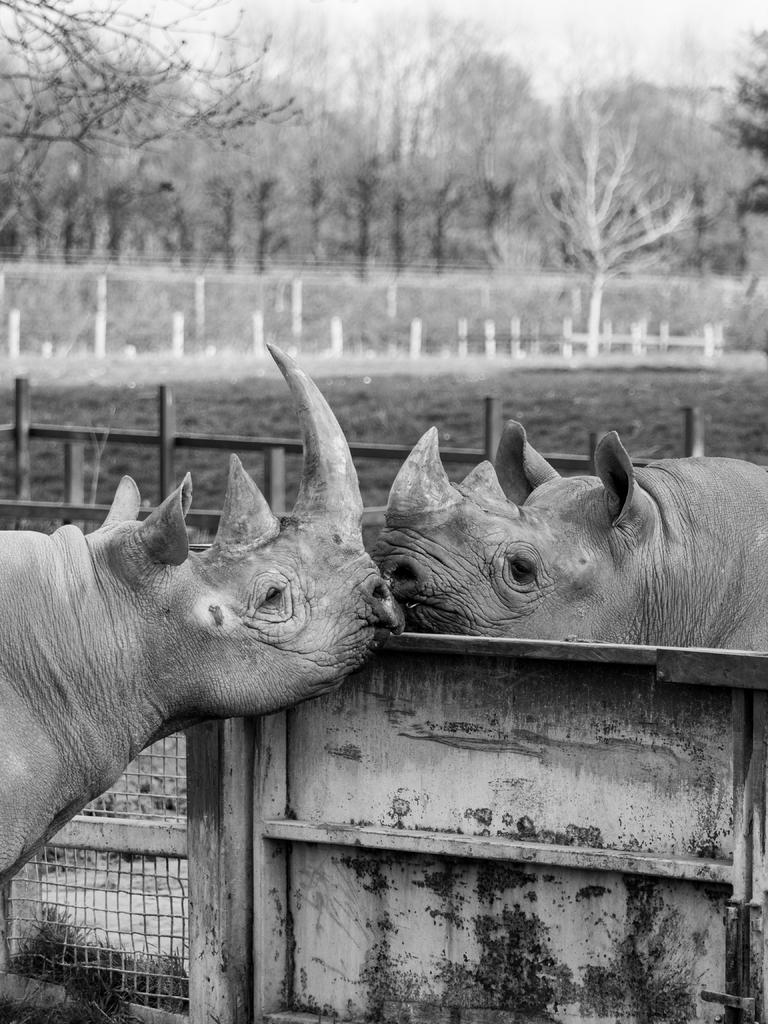What can be seen in the image? There are two animals in the image. Where are the animals located? The animals are at a fence. What can be seen in the distance in the image? There are trees in the background of the image. What texture can be seen on the line in the image? There is no line present in the image, so it is not possible to determine its texture. 